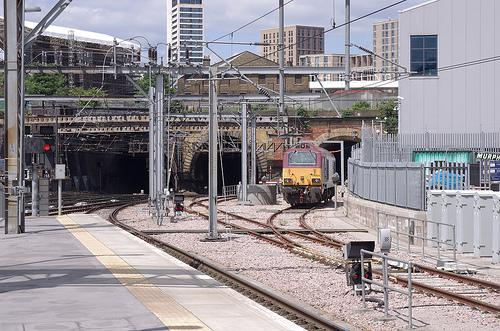Question: what is the train on?
Choices:
A. Road.
B. Hill.
C. Tracks.
D. Rocks.
Answer with the letter. Answer: C Question: what is behind the train?
Choices:
A. Buildings.
B. Trees.
C. Mountains.
D. Clouds.
Answer with the letter. Answer: A Question: how many trains?
Choices:
A. 2.
B. 3.
C. 4.
D. 1.
Answer with the letter. Answer: D Question: what did the train go through?
Choices:
A. Wall.
B. Cloud.
C. Tunnel.
D. Smoke.
Answer with the letter. Answer: C 